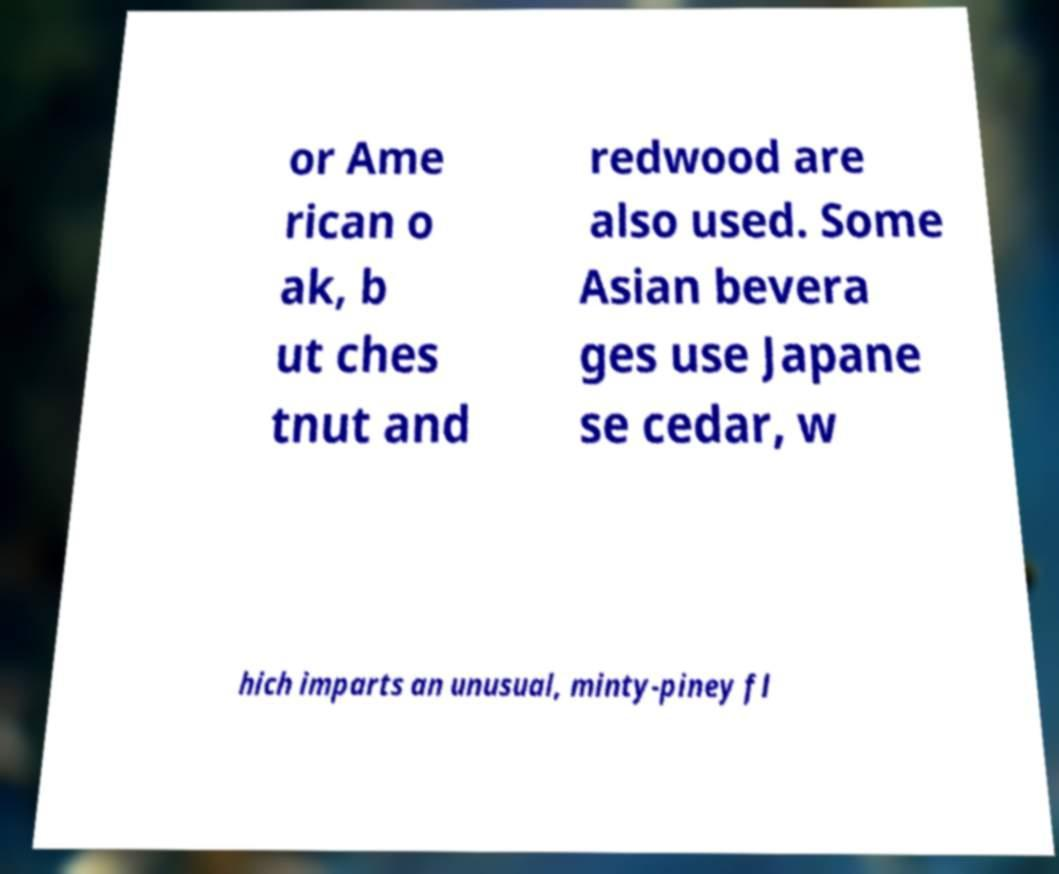Please read and relay the text visible in this image. What does it say? or Ame rican o ak, b ut ches tnut and redwood are also used. Some Asian bevera ges use Japane se cedar, w hich imparts an unusual, minty-piney fl 